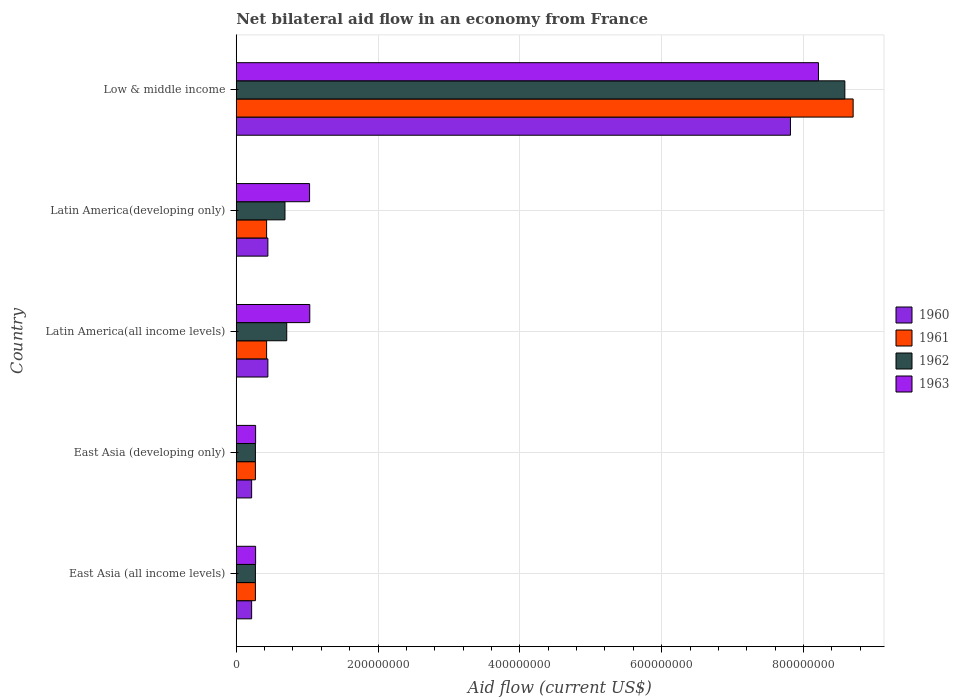How many groups of bars are there?
Keep it short and to the point. 5. Are the number of bars per tick equal to the number of legend labels?
Offer a very short reply. Yes. Are the number of bars on each tick of the Y-axis equal?
Provide a succinct answer. Yes. In how many cases, is the number of bars for a given country not equal to the number of legend labels?
Make the answer very short. 0. What is the net bilateral aid flow in 1960 in Latin America(all income levels)?
Your response must be concise. 4.46e+07. Across all countries, what is the maximum net bilateral aid flow in 1962?
Your answer should be very brief. 8.58e+08. Across all countries, what is the minimum net bilateral aid flow in 1961?
Make the answer very short. 2.70e+07. In which country was the net bilateral aid flow in 1963 minimum?
Provide a succinct answer. East Asia (all income levels). What is the total net bilateral aid flow in 1963 in the graph?
Offer a terse response. 1.08e+09. What is the difference between the net bilateral aid flow in 1962 in East Asia (developing only) and that in Latin America(all income levels)?
Offer a terse response. -4.42e+07. What is the difference between the net bilateral aid flow in 1960 in Latin America(all income levels) and the net bilateral aid flow in 1961 in East Asia (developing only)?
Provide a short and direct response. 1.76e+07. What is the average net bilateral aid flow in 1960 per country?
Keep it short and to the point. 1.83e+08. What is the ratio of the net bilateral aid flow in 1960 in East Asia (all income levels) to that in East Asia (developing only)?
Offer a terse response. 1. Is the net bilateral aid flow in 1960 in Latin America(all income levels) less than that in Low & middle income?
Provide a succinct answer. Yes. What is the difference between the highest and the second highest net bilateral aid flow in 1961?
Ensure brevity in your answer.  8.27e+08. What is the difference between the highest and the lowest net bilateral aid flow in 1961?
Your answer should be compact. 8.43e+08. Is the sum of the net bilateral aid flow in 1962 in East Asia (all income levels) and Low & middle income greater than the maximum net bilateral aid flow in 1963 across all countries?
Offer a terse response. Yes. Is it the case that in every country, the sum of the net bilateral aid flow in 1963 and net bilateral aid flow in 1962 is greater than the sum of net bilateral aid flow in 1960 and net bilateral aid flow in 1961?
Provide a short and direct response. No. What does the 4th bar from the bottom in East Asia (all income levels) represents?
Your response must be concise. 1963. How many bars are there?
Make the answer very short. 20. Are all the bars in the graph horizontal?
Keep it short and to the point. Yes. What is the difference between two consecutive major ticks on the X-axis?
Offer a terse response. 2.00e+08. Are the values on the major ticks of X-axis written in scientific E-notation?
Your answer should be compact. No. Does the graph contain any zero values?
Offer a very short reply. No. What is the title of the graph?
Ensure brevity in your answer.  Net bilateral aid flow in an economy from France. Does "1978" appear as one of the legend labels in the graph?
Keep it short and to the point. No. What is the label or title of the X-axis?
Offer a terse response. Aid flow (current US$). What is the Aid flow (current US$) of 1960 in East Asia (all income levels)?
Keep it short and to the point. 2.17e+07. What is the Aid flow (current US$) in 1961 in East Asia (all income levels)?
Make the answer very short. 2.70e+07. What is the Aid flow (current US$) of 1962 in East Asia (all income levels)?
Ensure brevity in your answer.  2.70e+07. What is the Aid flow (current US$) in 1963 in East Asia (all income levels)?
Give a very brief answer. 2.73e+07. What is the Aid flow (current US$) of 1960 in East Asia (developing only)?
Give a very brief answer. 2.17e+07. What is the Aid flow (current US$) in 1961 in East Asia (developing only)?
Offer a very short reply. 2.70e+07. What is the Aid flow (current US$) of 1962 in East Asia (developing only)?
Offer a terse response. 2.70e+07. What is the Aid flow (current US$) in 1963 in East Asia (developing only)?
Keep it short and to the point. 2.73e+07. What is the Aid flow (current US$) of 1960 in Latin America(all income levels)?
Make the answer very short. 4.46e+07. What is the Aid flow (current US$) in 1961 in Latin America(all income levels)?
Make the answer very short. 4.28e+07. What is the Aid flow (current US$) in 1962 in Latin America(all income levels)?
Your response must be concise. 7.12e+07. What is the Aid flow (current US$) of 1963 in Latin America(all income levels)?
Ensure brevity in your answer.  1.04e+08. What is the Aid flow (current US$) of 1960 in Latin America(developing only)?
Your answer should be compact. 4.46e+07. What is the Aid flow (current US$) in 1961 in Latin America(developing only)?
Ensure brevity in your answer.  4.28e+07. What is the Aid flow (current US$) in 1962 in Latin America(developing only)?
Your answer should be very brief. 6.87e+07. What is the Aid flow (current US$) of 1963 in Latin America(developing only)?
Your response must be concise. 1.03e+08. What is the Aid flow (current US$) of 1960 in Low & middle income?
Provide a succinct answer. 7.82e+08. What is the Aid flow (current US$) of 1961 in Low & middle income?
Make the answer very short. 8.70e+08. What is the Aid flow (current US$) in 1962 in Low & middle income?
Make the answer very short. 8.58e+08. What is the Aid flow (current US$) of 1963 in Low & middle income?
Offer a very short reply. 8.21e+08. Across all countries, what is the maximum Aid flow (current US$) in 1960?
Give a very brief answer. 7.82e+08. Across all countries, what is the maximum Aid flow (current US$) of 1961?
Ensure brevity in your answer.  8.70e+08. Across all countries, what is the maximum Aid flow (current US$) in 1962?
Provide a succinct answer. 8.58e+08. Across all countries, what is the maximum Aid flow (current US$) of 1963?
Give a very brief answer. 8.21e+08. Across all countries, what is the minimum Aid flow (current US$) of 1960?
Offer a very short reply. 2.17e+07. Across all countries, what is the minimum Aid flow (current US$) of 1961?
Your answer should be compact. 2.70e+07. Across all countries, what is the minimum Aid flow (current US$) of 1962?
Provide a succinct answer. 2.70e+07. Across all countries, what is the minimum Aid flow (current US$) in 1963?
Provide a succinct answer. 2.73e+07. What is the total Aid flow (current US$) in 1960 in the graph?
Make the answer very short. 9.14e+08. What is the total Aid flow (current US$) of 1961 in the graph?
Keep it short and to the point. 1.01e+09. What is the total Aid flow (current US$) of 1962 in the graph?
Provide a succinct answer. 1.05e+09. What is the total Aid flow (current US$) of 1963 in the graph?
Ensure brevity in your answer.  1.08e+09. What is the difference between the Aid flow (current US$) in 1962 in East Asia (all income levels) and that in East Asia (developing only)?
Your response must be concise. 0. What is the difference between the Aid flow (current US$) of 1960 in East Asia (all income levels) and that in Latin America(all income levels)?
Give a very brief answer. -2.29e+07. What is the difference between the Aid flow (current US$) of 1961 in East Asia (all income levels) and that in Latin America(all income levels)?
Make the answer very short. -1.58e+07. What is the difference between the Aid flow (current US$) of 1962 in East Asia (all income levels) and that in Latin America(all income levels)?
Your answer should be very brief. -4.42e+07. What is the difference between the Aid flow (current US$) in 1963 in East Asia (all income levels) and that in Latin America(all income levels)?
Give a very brief answer. -7.64e+07. What is the difference between the Aid flow (current US$) in 1960 in East Asia (all income levels) and that in Latin America(developing only)?
Ensure brevity in your answer.  -2.29e+07. What is the difference between the Aid flow (current US$) of 1961 in East Asia (all income levels) and that in Latin America(developing only)?
Offer a very short reply. -1.58e+07. What is the difference between the Aid flow (current US$) in 1962 in East Asia (all income levels) and that in Latin America(developing only)?
Your answer should be very brief. -4.17e+07. What is the difference between the Aid flow (current US$) of 1963 in East Asia (all income levels) and that in Latin America(developing only)?
Offer a very short reply. -7.61e+07. What is the difference between the Aid flow (current US$) of 1960 in East Asia (all income levels) and that in Low & middle income?
Make the answer very short. -7.60e+08. What is the difference between the Aid flow (current US$) in 1961 in East Asia (all income levels) and that in Low & middle income?
Give a very brief answer. -8.43e+08. What is the difference between the Aid flow (current US$) in 1962 in East Asia (all income levels) and that in Low & middle income?
Ensure brevity in your answer.  -8.31e+08. What is the difference between the Aid flow (current US$) of 1963 in East Asia (all income levels) and that in Low & middle income?
Your answer should be very brief. -7.94e+08. What is the difference between the Aid flow (current US$) in 1960 in East Asia (developing only) and that in Latin America(all income levels)?
Provide a short and direct response. -2.29e+07. What is the difference between the Aid flow (current US$) of 1961 in East Asia (developing only) and that in Latin America(all income levels)?
Offer a very short reply. -1.58e+07. What is the difference between the Aid flow (current US$) in 1962 in East Asia (developing only) and that in Latin America(all income levels)?
Offer a terse response. -4.42e+07. What is the difference between the Aid flow (current US$) of 1963 in East Asia (developing only) and that in Latin America(all income levels)?
Provide a succinct answer. -7.64e+07. What is the difference between the Aid flow (current US$) of 1960 in East Asia (developing only) and that in Latin America(developing only)?
Give a very brief answer. -2.29e+07. What is the difference between the Aid flow (current US$) of 1961 in East Asia (developing only) and that in Latin America(developing only)?
Provide a succinct answer. -1.58e+07. What is the difference between the Aid flow (current US$) of 1962 in East Asia (developing only) and that in Latin America(developing only)?
Offer a terse response. -4.17e+07. What is the difference between the Aid flow (current US$) of 1963 in East Asia (developing only) and that in Latin America(developing only)?
Offer a very short reply. -7.61e+07. What is the difference between the Aid flow (current US$) of 1960 in East Asia (developing only) and that in Low & middle income?
Your answer should be very brief. -7.60e+08. What is the difference between the Aid flow (current US$) of 1961 in East Asia (developing only) and that in Low & middle income?
Your response must be concise. -8.43e+08. What is the difference between the Aid flow (current US$) in 1962 in East Asia (developing only) and that in Low & middle income?
Your response must be concise. -8.31e+08. What is the difference between the Aid flow (current US$) of 1963 in East Asia (developing only) and that in Low & middle income?
Your answer should be very brief. -7.94e+08. What is the difference between the Aid flow (current US$) in 1960 in Latin America(all income levels) and that in Latin America(developing only)?
Make the answer very short. 0. What is the difference between the Aid flow (current US$) in 1962 in Latin America(all income levels) and that in Latin America(developing only)?
Make the answer very short. 2.50e+06. What is the difference between the Aid flow (current US$) of 1960 in Latin America(all income levels) and that in Low & middle income?
Provide a succinct answer. -7.37e+08. What is the difference between the Aid flow (current US$) of 1961 in Latin America(all income levels) and that in Low & middle income?
Your answer should be compact. -8.27e+08. What is the difference between the Aid flow (current US$) of 1962 in Latin America(all income levels) and that in Low & middle income?
Provide a succinct answer. -7.87e+08. What is the difference between the Aid flow (current US$) in 1963 in Latin America(all income levels) and that in Low & middle income?
Give a very brief answer. -7.17e+08. What is the difference between the Aid flow (current US$) in 1960 in Latin America(developing only) and that in Low & middle income?
Offer a very short reply. -7.37e+08. What is the difference between the Aid flow (current US$) of 1961 in Latin America(developing only) and that in Low & middle income?
Your response must be concise. -8.27e+08. What is the difference between the Aid flow (current US$) of 1962 in Latin America(developing only) and that in Low & middle income?
Provide a succinct answer. -7.90e+08. What is the difference between the Aid flow (current US$) in 1963 in Latin America(developing only) and that in Low & middle income?
Offer a terse response. -7.18e+08. What is the difference between the Aid flow (current US$) of 1960 in East Asia (all income levels) and the Aid flow (current US$) of 1961 in East Asia (developing only)?
Give a very brief answer. -5.30e+06. What is the difference between the Aid flow (current US$) of 1960 in East Asia (all income levels) and the Aid flow (current US$) of 1962 in East Asia (developing only)?
Provide a succinct answer. -5.30e+06. What is the difference between the Aid flow (current US$) in 1960 in East Asia (all income levels) and the Aid flow (current US$) in 1963 in East Asia (developing only)?
Offer a very short reply. -5.60e+06. What is the difference between the Aid flow (current US$) in 1961 in East Asia (all income levels) and the Aid flow (current US$) in 1962 in East Asia (developing only)?
Ensure brevity in your answer.  0. What is the difference between the Aid flow (current US$) of 1960 in East Asia (all income levels) and the Aid flow (current US$) of 1961 in Latin America(all income levels)?
Your answer should be compact. -2.11e+07. What is the difference between the Aid flow (current US$) in 1960 in East Asia (all income levels) and the Aid flow (current US$) in 1962 in Latin America(all income levels)?
Make the answer very short. -4.95e+07. What is the difference between the Aid flow (current US$) of 1960 in East Asia (all income levels) and the Aid flow (current US$) of 1963 in Latin America(all income levels)?
Give a very brief answer. -8.20e+07. What is the difference between the Aid flow (current US$) in 1961 in East Asia (all income levels) and the Aid flow (current US$) in 1962 in Latin America(all income levels)?
Offer a terse response. -4.42e+07. What is the difference between the Aid flow (current US$) in 1961 in East Asia (all income levels) and the Aid flow (current US$) in 1963 in Latin America(all income levels)?
Your answer should be very brief. -7.67e+07. What is the difference between the Aid flow (current US$) of 1962 in East Asia (all income levels) and the Aid flow (current US$) of 1963 in Latin America(all income levels)?
Ensure brevity in your answer.  -7.67e+07. What is the difference between the Aid flow (current US$) in 1960 in East Asia (all income levels) and the Aid flow (current US$) in 1961 in Latin America(developing only)?
Your answer should be compact. -2.11e+07. What is the difference between the Aid flow (current US$) of 1960 in East Asia (all income levels) and the Aid flow (current US$) of 1962 in Latin America(developing only)?
Keep it short and to the point. -4.70e+07. What is the difference between the Aid flow (current US$) in 1960 in East Asia (all income levels) and the Aid flow (current US$) in 1963 in Latin America(developing only)?
Give a very brief answer. -8.17e+07. What is the difference between the Aid flow (current US$) of 1961 in East Asia (all income levels) and the Aid flow (current US$) of 1962 in Latin America(developing only)?
Keep it short and to the point. -4.17e+07. What is the difference between the Aid flow (current US$) of 1961 in East Asia (all income levels) and the Aid flow (current US$) of 1963 in Latin America(developing only)?
Provide a short and direct response. -7.64e+07. What is the difference between the Aid flow (current US$) in 1962 in East Asia (all income levels) and the Aid flow (current US$) in 1963 in Latin America(developing only)?
Offer a terse response. -7.64e+07. What is the difference between the Aid flow (current US$) in 1960 in East Asia (all income levels) and the Aid flow (current US$) in 1961 in Low & middle income?
Offer a very short reply. -8.48e+08. What is the difference between the Aid flow (current US$) of 1960 in East Asia (all income levels) and the Aid flow (current US$) of 1962 in Low & middle income?
Ensure brevity in your answer.  -8.37e+08. What is the difference between the Aid flow (current US$) in 1960 in East Asia (all income levels) and the Aid flow (current US$) in 1963 in Low & middle income?
Provide a succinct answer. -7.99e+08. What is the difference between the Aid flow (current US$) of 1961 in East Asia (all income levels) and the Aid flow (current US$) of 1962 in Low & middle income?
Offer a terse response. -8.31e+08. What is the difference between the Aid flow (current US$) of 1961 in East Asia (all income levels) and the Aid flow (current US$) of 1963 in Low & middle income?
Make the answer very short. -7.94e+08. What is the difference between the Aid flow (current US$) of 1962 in East Asia (all income levels) and the Aid flow (current US$) of 1963 in Low & middle income?
Offer a very short reply. -7.94e+08. What is the difference between the Aid flow (current US$) of 1960 in East Asia (developing only) and the Aid flow (current US$) of 1961 in Latin America(all income levels)?
Make the answer very short. -2.11e+07. What is the difference between the Aid flow (current US$) in 1960 in East Asia (developing only) and the Aid flow (current US$) in 1962 in Latin America(all income levels)?
Keep it short and to the point. -4.95e+07. What is the difference between the Aid flow (current US$) of 1960 in East Asia (developing only) and the Aid flow (current US$) of 1963 in Latin America(all income levels)?
Provide a short and direct response. -8.20e+07. What is the difference between the Aid flow (current US$) of 1961 in East Asia (developing only) and the Aid flow (current US$) of 1962 in Latin America(all income levels)?
Ensure brevity in your answer.  -4.42e+07. What is the difference between the Aid flow (current US$) in 1961 in East Asia (developing only) and the Aid flow (current US$) in 1963 in Latin America(all income levels)?
Offer a terse response. -7.67e+07. What is the difference between the Aid flow (current US$) in 1962 in East Asia (developing only) and the Aid flow (current US$) in 1963 in Latin America(all income levels)?
Provide a short and direct response. -7.67e+07. What is the difference between the Aid flow (current US$) of 1960 in East Asia (developing only) and the Aid flow (current US$) of 1961 in Latin America(developing only)?
Provide a short and direct response. -2.11e+07. What is the difference between the Aid flow (current US$) in 1960 in East Asia (developing only) and the Aid flow (current US$) in 1962 in Latin America(developing only)?
Provide a succinct answer. -4.70e+07. What is the difference between the Aid flow (current US$) of 1960 in East Asia (developing only) and the Aid flow (current US$) of 1963 in Latin America(developing only)?
Keep it short and to the point. -8.17e+07. What is the difference between the Aid flow (current US$) of 1961 in East Asia (developing only) and the Aid flow (current US$) of 1962 in Latin America(developing only)?
Provide a short and direct response. -4.17e+07. What is the difference between the Aid flow (current US$) in 1961 in East Asia (developing only) and the Aid flow (current US$) in 1963 in Latin America(developing only)?
Ensure brevity in your answer.  -7.64e+07. What is the difference between the Aid flow (current US$) in 1962 in East Asia (developing only) and the Aid flow (current US$) in 1963 in Latin America(developing only)?
Your response must be concise. -7.64e+07. What is the difference between the Aid flow (current US$) in 1960 in East Asia (developing only) and the Aid flow (current US$) in 1961 in Low & middle income?
Your answer should be very brief. -8.48e+08. What is the difference between the Aid flow (current US$) of 1960 in East Asia (developing only) and the Aid flow (current US$) of 1962 in Low & middle income?
Provide a short and direct response. -8.37e+08. What is the difference between the Aid flow (current US$) in 1960 in East Asia (developing only) and the Aid flow (current US$) in 1963 in Low & middle income?
Ensure brevity in your answer.  -7.99e+08. What is the difference between the Aid flow (current US$) of 1961 in East Asia (developing only) and the Aid flow (current US$) of 1962 in Low & middle income?
Your answer should be very brief. -8.31e+08. What is the difference between the Aid flow (current US$) of 1961 in East Asia (developing only) and the Aid flow (current US$) of 1963 in Low & middle income?
Give a very brief answer. -7.94e+08. What is the difference between the Aid flow (current US$) in 1962 in East Asia (developing only) and the Aid flow (current US$) in 1963 in Low & middle income?
Make the answer very short. -7.94e+08. What is the difference between the Aid flow (current US$) in 1960 in Latin America(all income levels) and the Aid flow (current US$) in 1961 in Latin America(developing only)?
Your answer should be very brief. 1.80e+06. What is the difference between the Aid flow (current US$) in 1960 in Latin America(all income levels) and the Aid flow (current US$) in 1962 in Latin America(developing only)?
Your answer should be compact. -2.41e+07. What is the difference between the Aid flow (current US$) in 1960 in Latin America(all income levels) and the Aid flow (current US$) in 1963 in Latin America(developing only)?
Provide a succinct answer. -5.88e+07. What is the difference between the Aid flow (current US$) of 1961 in Latin America(all income levels) and the Aid flow (current US$) of 1962 in Latin America(developing only)?
Make the answer very short. -2.59e+07. What is the difference between the Aid flow (current US$) in 1961 in Latin America(all income levels) and the Aid flow (current US$) in 1963 in Latin America(developing only)?
Your response must be concise. -6.06e+07. What is the difference between the Aid flow (current US$) of 1962 in Latin America(all income levels) and the Aid flow (current US$) of 1963 in Latin America(developing only)?
Your answer should be compact. -3.22e+07. What is the difference between the Aid flow (current US$) in 1960 in Latin America(all income levels) and the Aid flow (current US$) in 1961 in Low & middle income?
Provide a short and direct response. -8.25e+08. What is the difference between the Aid flow (current US$) in 1960 in Latin America(all income levels) and the Aid flow (current US$) in 1962 in Low & middle income?
Your answer should be very brief. -8.14e+08. What is the difference between the Aid flow (current US$) of 1960 in Latin America(all income levels) and the Aid flow (current US$) of 1963 in Low & middle income?
Offer a terse response. -7.76e+08. What is the difference between the Aid flow (current US$) in 1961 in Latin America(all income levels) and the Aid flow (current US$) in 1962 in Low & middle income?
Ensure brevity in your answer.  -8.16e+08. What is the difference between the Aid flow (current US$) in 1961 in Latin America(all income levels) and the Aid flow (current US$) in 1963 in Low & middle income?
Keep it short and to the point. -7.78e+08. What is the difference between the Aid flow (current US$) of 1962 in Latin America(all income levels) and the Aid flow (current US$) of 1963 in Low & middle income?
Provide a short and direct response. -7.50e+08. What is the difference between the Aid flow (current US$) of 1960 in Latin America(developing only) and the Aid flow (current US$) of 1961 in Low & middle income?
Your answer should be very brief. -8.25e+08. What is the difference between the Aid flow (current US$) of 1960 in Latin America(developing only) and the Aid flow (current US$) of 1962 in Low & middle income?
Make the answer very short. -8.14e+08. What is the difference between the Aid flow (current US$) of 1960 in Latin America(developing only) and the Aid flow (current US$) of 1963 in Low & middle income?
Your response must be concise. -7.76e+08. What is the difference between the Aid flow (current US$) in 1961 in Latin America(developing only) and the Aid flow (current US$) in 1962 in Low & middle income?
Your response must be concise. -8.16e+08. What is the difference between the Aid flow (current US$) in 1961 in Latin America(developing only) and the Aid flow (current US$) in 1963 in Low & middle income?
Ensure brevity in your answer.  -7.78e+08. What is the difference between the Aid flow (current US$) of 1962 in Latin America(developing only) and the Aid flow (current US$) of 1963 in Low & middle income?
Ensure brevity in your answer.  -7.52e+08. What is the average Aid flow (current US$) of 1960 per country?
Offer a very short reply. 1.83e+08. What is the average Aid flow (current US$) in 1961 per country?
Your answer should be very brief. 2.02e+08. What is the average Aid flow (current US$) of 1962 per country?
Ensure brevity in your answer.  2.10e+08. What is the average Aid flow (current US$) of 1963 per country?
Your answer should be compact. 2.17e+08. What is the difference between the Aid flow (current US$) in 1960 and Aid flow (current US$) in 1961 in East Asia (all income levels)?
Your answer should be very brief. -5.30e+06. What is the difference between the Aid flow (current US$) in 1960 and Aid flow (current US$) in 1962 in East Asia (all income levels)?
Keep it short and to the point. -5.30e+06. What is the difference between the Aid flow (current US$) of 1960 and Aid flow (current US$) of 1963 in East Asia (all income levels)?
Make the answer very short. -5.60e+06. What is the difference between the Aid flow (current US$) of 1962 and Aid flow (current US$) of 1963 in East Asia (all income levels)?
Offer a terse response. -3.00e+05. What is the difference between the Aid flow (current US$) of 1960 and Aid flow (current US$) of 1961 in East Asia (developing only)?
Keep it short and to the point. -5.30e+06. What is the difference between the Aid flow (current US$) of 1960 and Aid flow (current US$) of 1962 in East Asia (developing only)?
Offer a terse response. -5.30e+06. What is the difference between the Aid flow (current US$) in 1960 and Aid flow (current US$) in 1963 in East Asia (developing only)?
Provide a succinct answer. -5.60e+06. What is the difference between the Aid flow (current US$) in 1961 and Aid flow (current US$) in 1963 in East Asia (developing only)?
Your response must be concise. -3.00e+05. What is the difference between the Aid flow (current US$) of 1960 and Aid flow (current US$) of 1961 in Latin America(all income levels)?
Ensure brevity in your answer.  1.80e+06. What is the difference between the Aid flow (current US$) of 1960 and Aid flow (current US$) of 1962 in Latin America(all income levels)?
Make the answer very short. -2.66e+07. What is the difference between the Aid flow (current US$) in 1960 and Aid flow (current US$) in 1963 in Latin America(all income levels)?
Your response must be concise. -5.91e+07. What is the difference between the Aid flow (current US$) in 1961 and Aid flow (current US$) in 1962 in Latin America(all income levels)?
Provide a short and direct response. -2.84e+07. What is the difference between the Aid flow (current US$) of 1961 and Aid flow (current US$) of 1963 in Latin America(all income levels)?
Offer a very short reply. -6.09e+07. What is the difference between the Aid flow (current US$) in 1962 and Aid flow (current US$) in 1963 in Latin America(all income levels)?
Your answer should be compact. -3.25e+07. What is the difference between the Aid flow (current US$) of 1960 and Aid flow (current US$) of 1961 in Latin America(developing only)?
Offer a very short reply. 1.80e+06. What is the difference between the Aid flow (current US$) of 1960 and Aid flow (current US$) of 1962 in Latin America(developing only)?
Provide a succinct answer. -2.41e+07. What is the difference between the Aid flow (current US$) of 1960 and Aid flow (current US$) of 1963 in Latin America(developing only)?
Your response must be concise. -5.88e+07. What is the difference between the Aid flow (current US$) of 1961 and Aid flow (current US$) of 1962 in Latin America(developing only)?
Ensure brevity in your answer.  -2.59e+07. What is the difference between the Aid flow (current US$) of 1961 and Aid flow (current US$) of 1963 in Latin America(developing only)?
Give a very brief answer. -6.06e+07. What is the difference between the Aid flow (current US$) of 1962 and Aid flow (current US$) of 1963 in Latin America(developing only)?
Offer a terse response. -3.47e+07. What is the difference between the Aid flow (current US$) in 1960 and Aid flow (current US$) in 1961 in Low & middle income?
Your answer should be very brief. -8.84e+07. What is the difference between the Aid flow (current US$) of 1960 and Aid flow (current US$) of 1962 in Low & middle income?
Offer a terse response. -7.67e+07. What is the difference between the Aid flow (current US$) in 1960 and Aid flow (current US$) in 1963 in Low & middle income?
Your answer should be compact. -3.95e+07. What is the difference between the Aid flow (current US$) of 1961 and Aid flow (current US$) of 1962 in Low & middle income?
Give a very brief answer. 1.17e+07. What is the difference between the Aid flow (current US$) in 1961 and Aid flow (current US$) in 1963 in Low & middle income?
Ensure brevity in your answer.  4.89e+07. What is the difference between the Aid flow (current US$) in 1962 and Aid flow (current US$) in 1963 in Low & middle income?
Your answer should be very brief. 3.72e+07. What is the ratio of the Aid flow (current US$) in 1960 in East Asia (all income levels) to that in East Asia (developing only)?
Provide a succinct answer. 1. What is the ratio of the Aid flow (current US$) in 1961 in East Asia (all income levels) to that in East Asia (developing only)?
Offer a very short reply. 1. What is the ratio of the Aid flow (current US$) in 1962 in East Asia (all income levels) to that in East Asia (developing only)?
Provide a short and direct response. 1. What is the ratio of the Aid flow (current US$) in 1960 in East Asia (all income levels) to that in Latin America(all income levels)?
Offer a very short reply. 0.49. What is the ratio of the Aid flow (current US$) in 1961 in East Asia (all income levels) to that in Latin America(all income levels)?
Make the answer very short. 0.63. What is the ratio of the Aid flow (current US$) of 1962 in East Asia (all income levels) to that in Latin America(all income levels)?
Your response must be concise. 0.38. What is the ratio of the Aid flow (current US$) of 1963 in East Asia (all income levels) to that in Latin America(all income levels)?
Give a very brief answer. 0.26. What is the ratio of the Aid flow (current US$) in 1960 in East Asia (all income levels) to that in Latin America(developing only)?
Offer a very short reply. 0.49. What is the ratio of the Aid flow (current US$) of 1961 in East Asia (all income levels) to that in Latin America(developing only)?
Your response must be concise. 0.63. What is the ratio of the Aid flow (current US$) in 1962 in East Asia (all income levels) to that in Latin America(developing only)?
Your response must be concise. 0.39. What is the ratio of the Aid flow (current US$) of 1963 in East Asia (all income levels) to that in Latin America(developing only)?
Keep it short and to the point. 0.26. What is the ratio of the Aid flow (current US$) of 1960 in East Asia (all income levels) to that in Low & middle income?
Provide a short and direct response. 0.03. What is the ratio of the Aid flow (current US$) in 1961 in East Asia (all income levels) to that in Low & middle income?
Offer a very short reply. 0.03. What is the ratio of the Aid flow (current US$) of 1962 in East Asia (all income levels) to that in Low & middle income?
Offer a terse response. 0.03. What is the ratio of the Aid flow (current US$) in 1963 in East Asia (all income levels) to that in Low & middle income?
Keep it short and to the point. 0.03. What is the ratio of the Aid flow (current US$) of 1960 in East Asia (developing only) to that in Latin America(all income levels)?
Your answer should be very brief. 0.49. What is the ratio of the Aid flow (current US$) in 1961 in East Asia (developing only) to that in Latin America(all income levels)?
Ensure brevity in your answer.  0.63. What is the ratio of the Aid flow (current US$) in 1962 in East Asia (developing only) to that in Latin America(all income levels)?
Offer a terse response. 0.38. What is the ratio of the Aid flow (current US$) in 1963 in East Asia (developing only) to that in Latin America(all income levels)?
Your response must be concise. 0.26. What is the ratio of the Aid flow (current US$) in 1960 in East Asia (developing only) to that in Latin America(developing only)?
Provide a succinct answer. 0.49. What is the ratio of the Aid flow (current US$) of 1961 in East Asia (developing only) to that in Latin America(developing only)?
Keep it short and to the point. 0.63. What is the ratio of the Aid flow (current US$) in 1962 in East Asia (developing only) to that in Latin America(developing only)?
Provide a short and direct response. 0.39. What is the ratio of the Aid flow (current US$) in 1963 in East Asia (developing only) to that in Latin America(developing only)?
Your answer should be compact. 0.26. What is the ratio of the Aid flow (current US$) of 1960 in East Asia (developing only) to that in Low & middle income?
Keep it short and to the point. 0.03. What is the ratio of the Aid flow (current US$) of 1961 in East Asia (developing only) to that in Low & middle income?
Keep it short and to the point. 0.03. What is the ratio of the Aid flow (current US$) in 1962 in East Asia (developing only) to that in Low & middle income?
Keep it short and to the point. 0.03. What is the ratio of the Aid flow (current US$) in 1963 in East Asia (developing only) to that in Low & middle income?
Provide a short and direct response. 0.03. What is the ratio of the Aid flow (current US$) of 1961 in Latin America(all income levels) to that in Latin America(developing only)?
Offer a very short reply. 1. What is the ratio of the Aid flow (current US$) of 1962 in Latin America(all income levels) to that in Latin America(developing only)?
Make the answer very short. 1.04. What is the ratio of the Aid flow (current US$) of 1963 in Latin America(all income levels) to that in Latin America(developing only)?
Make the answer very short. 1. What is the ratio of the Aid flow (current US$) in 1960 in Latin America(all income levels) to that in Low & middle income?
Ensure brevity in your answer.  0.06. What is the ratio of the Aid flow (current US$) in 1961 in Latin America(all income levels) to that in Low & middle income?
Your answer should be very brief. 0.05. What is the ratio of the Aid flow (current US$) in 1962 in Latin America(all income levels) to that in Low & middle income?
Make the answer very short. 0.08. What is the ratio of the Aid flow (current US$) of 1963 in Latin America(all income levels) to that in Low & middle income?
Your response must be concise. 0.13. What is the ratio of the Aid flow (current US$) in 1960 in Latin America(developing only) to that in Low & middle income?
Keep it short and to the point. 0.06. What is the ratio of the Aid flow (current US$) in 1961 in Latin America(developing only) to that in Low & middle income?
Give a very brief answer. 0.05. What is the ratio of the Aid flow (current US$) in 1962 in Latin America(developing only) to that in Low & middle income?
Ensure brevity in your answer.  0.08. What is the ratio of the Aid flow (current US$) of 1963 in Latin America(developing only) to that in Low & middle income?
Offer a very short reply. 0.13. What is the difference between the highest and the second highest Aid flow (current US$) of 1960?
Offer a very short reply. 7.37e+08. What is the difference between the highest and the second highest Aid flow (current US$) in 1961?
Give a very brief answer. 8.27e+08. What is the difference between the highest and the second highest Aid flow (current US$) of 1962?
Your answer should be compact. 7.87e+08. What is the difference between the highest and the second highest Aid flow (current US$) of 1963?
Offer a terse response. 7.17e+08. What is the difference between the highest and the lowest Aid flow (current US$) in 1960?
Keep it short and to the point. 7.60e+08. What is the difference between the highest and the lowest Aid flow (current US$) in 1961?
Give a very brief answer. 8.43e+08. What is the difference between the highest and the lowest Aid flow (current US$) in 1962?
Provide a short and direct response. 8.31e+08. What is the difference between the highest and the lowest Aid flow (current US$) of 1963?
Provide a short and direct response. 7.94e+08. 